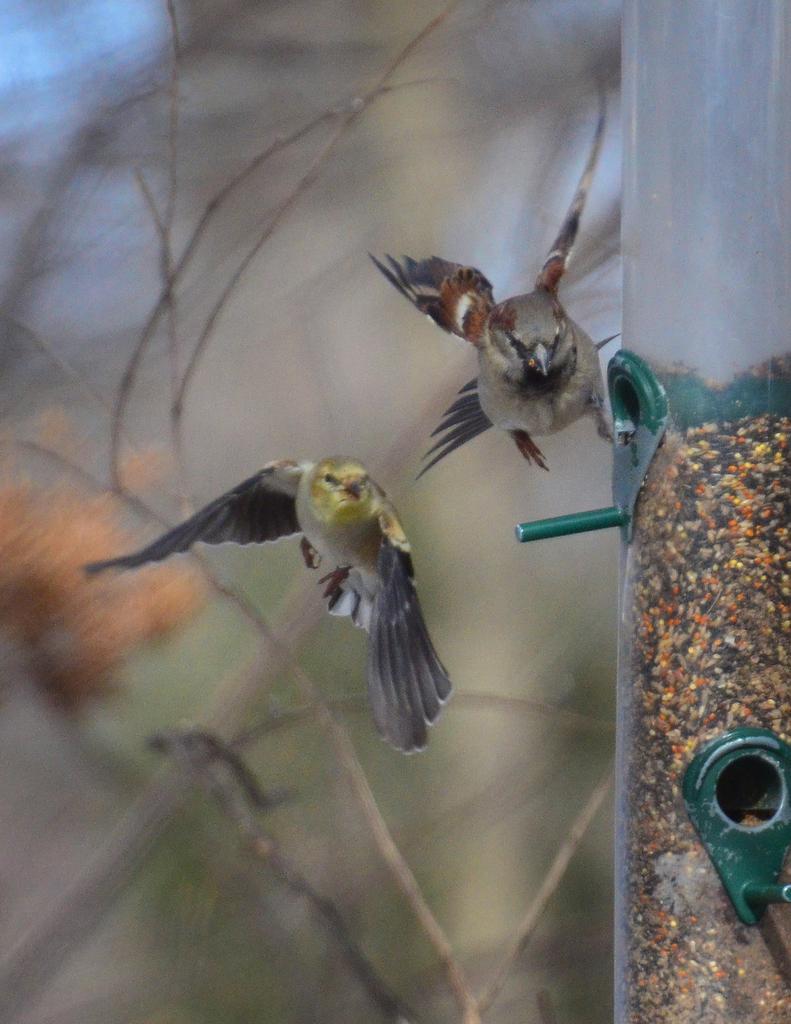In one or two sentences, can you explain what this image depicts? In the image in the center we can see one pole and two birds flying. In the background we can see trees. 